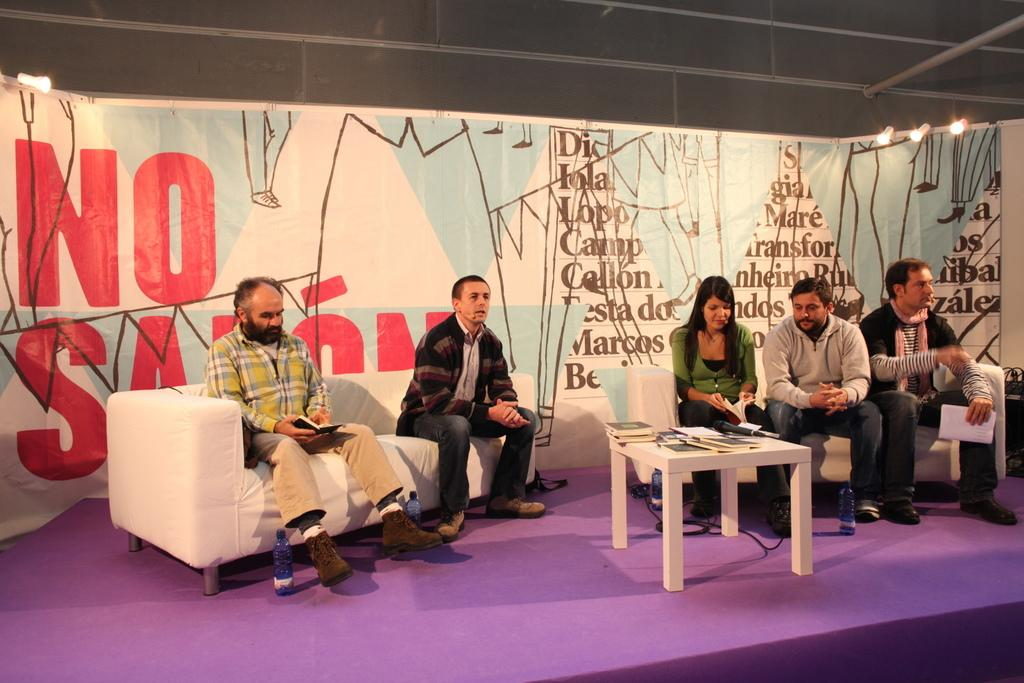Who is present in the image? There are men and women in the image. Where are they sitting? They are sitting on a sofa on a stage. What is in front of the sofa? There is a table in front of the sofa. What is on the table? There are papers on the table. What type of hat is the man wearing in the image? There is no man wearing a hat in the image. Can you describe the room where the people are sitting? The provided facts do not mention a room, only a stage. 